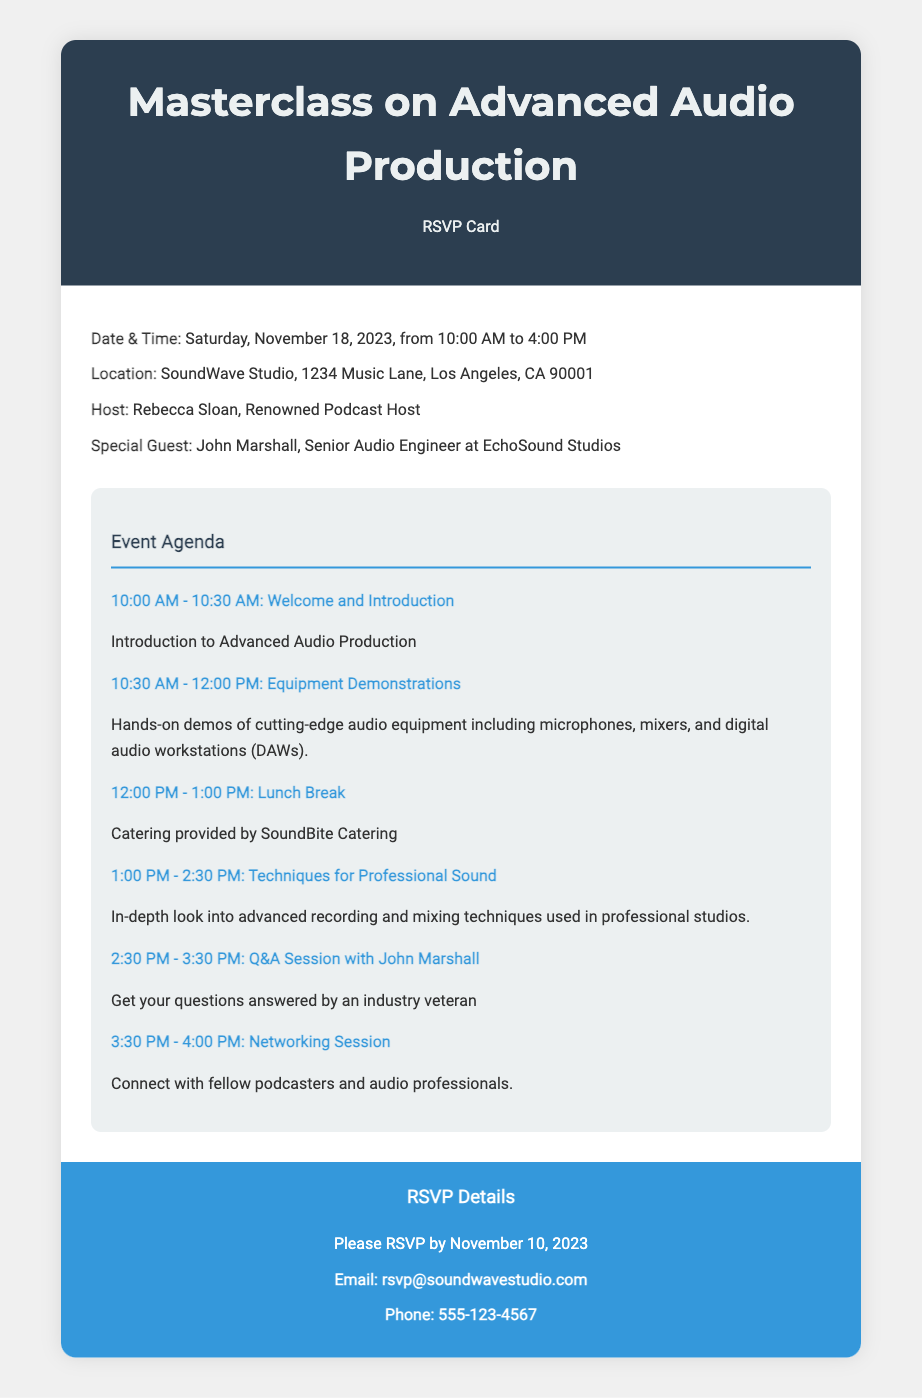What is the date of the masterclass? The date is specified in the details section as Saturday, November 18, 2023.
Answer: November 18, 2023 Who is the special guest at the masterclass? The special guest is mentioned in the details section of the document.
Answer: John Marshall What time does the event start? The start time can be found in the details section of the document.
Answer: 10:00 AM What is provided during the lunch break? The lunch break describes what will be provided, mentioned in the agenda section.
Answer: Catering by SoundBite Catering How long is the Q&A session with John Marshall? The duration of the Q&A session is detailed in the agenda section of the document.
Answer: 1 hour What is the RSVP deadline? The RSVP deadline is stated in the RSVP details section of the document.
Answer: November 10, 2023 What activities are included in the networking session? The networking session description provides insight into the activities expected during this time.
Answer: Connect with fellow podcasters and audio professionals What topic is covered during the 1:00 PM session? The topic for the specified session can be found in the agenda section of the document.
Answer: Techniques for Professional Sound 